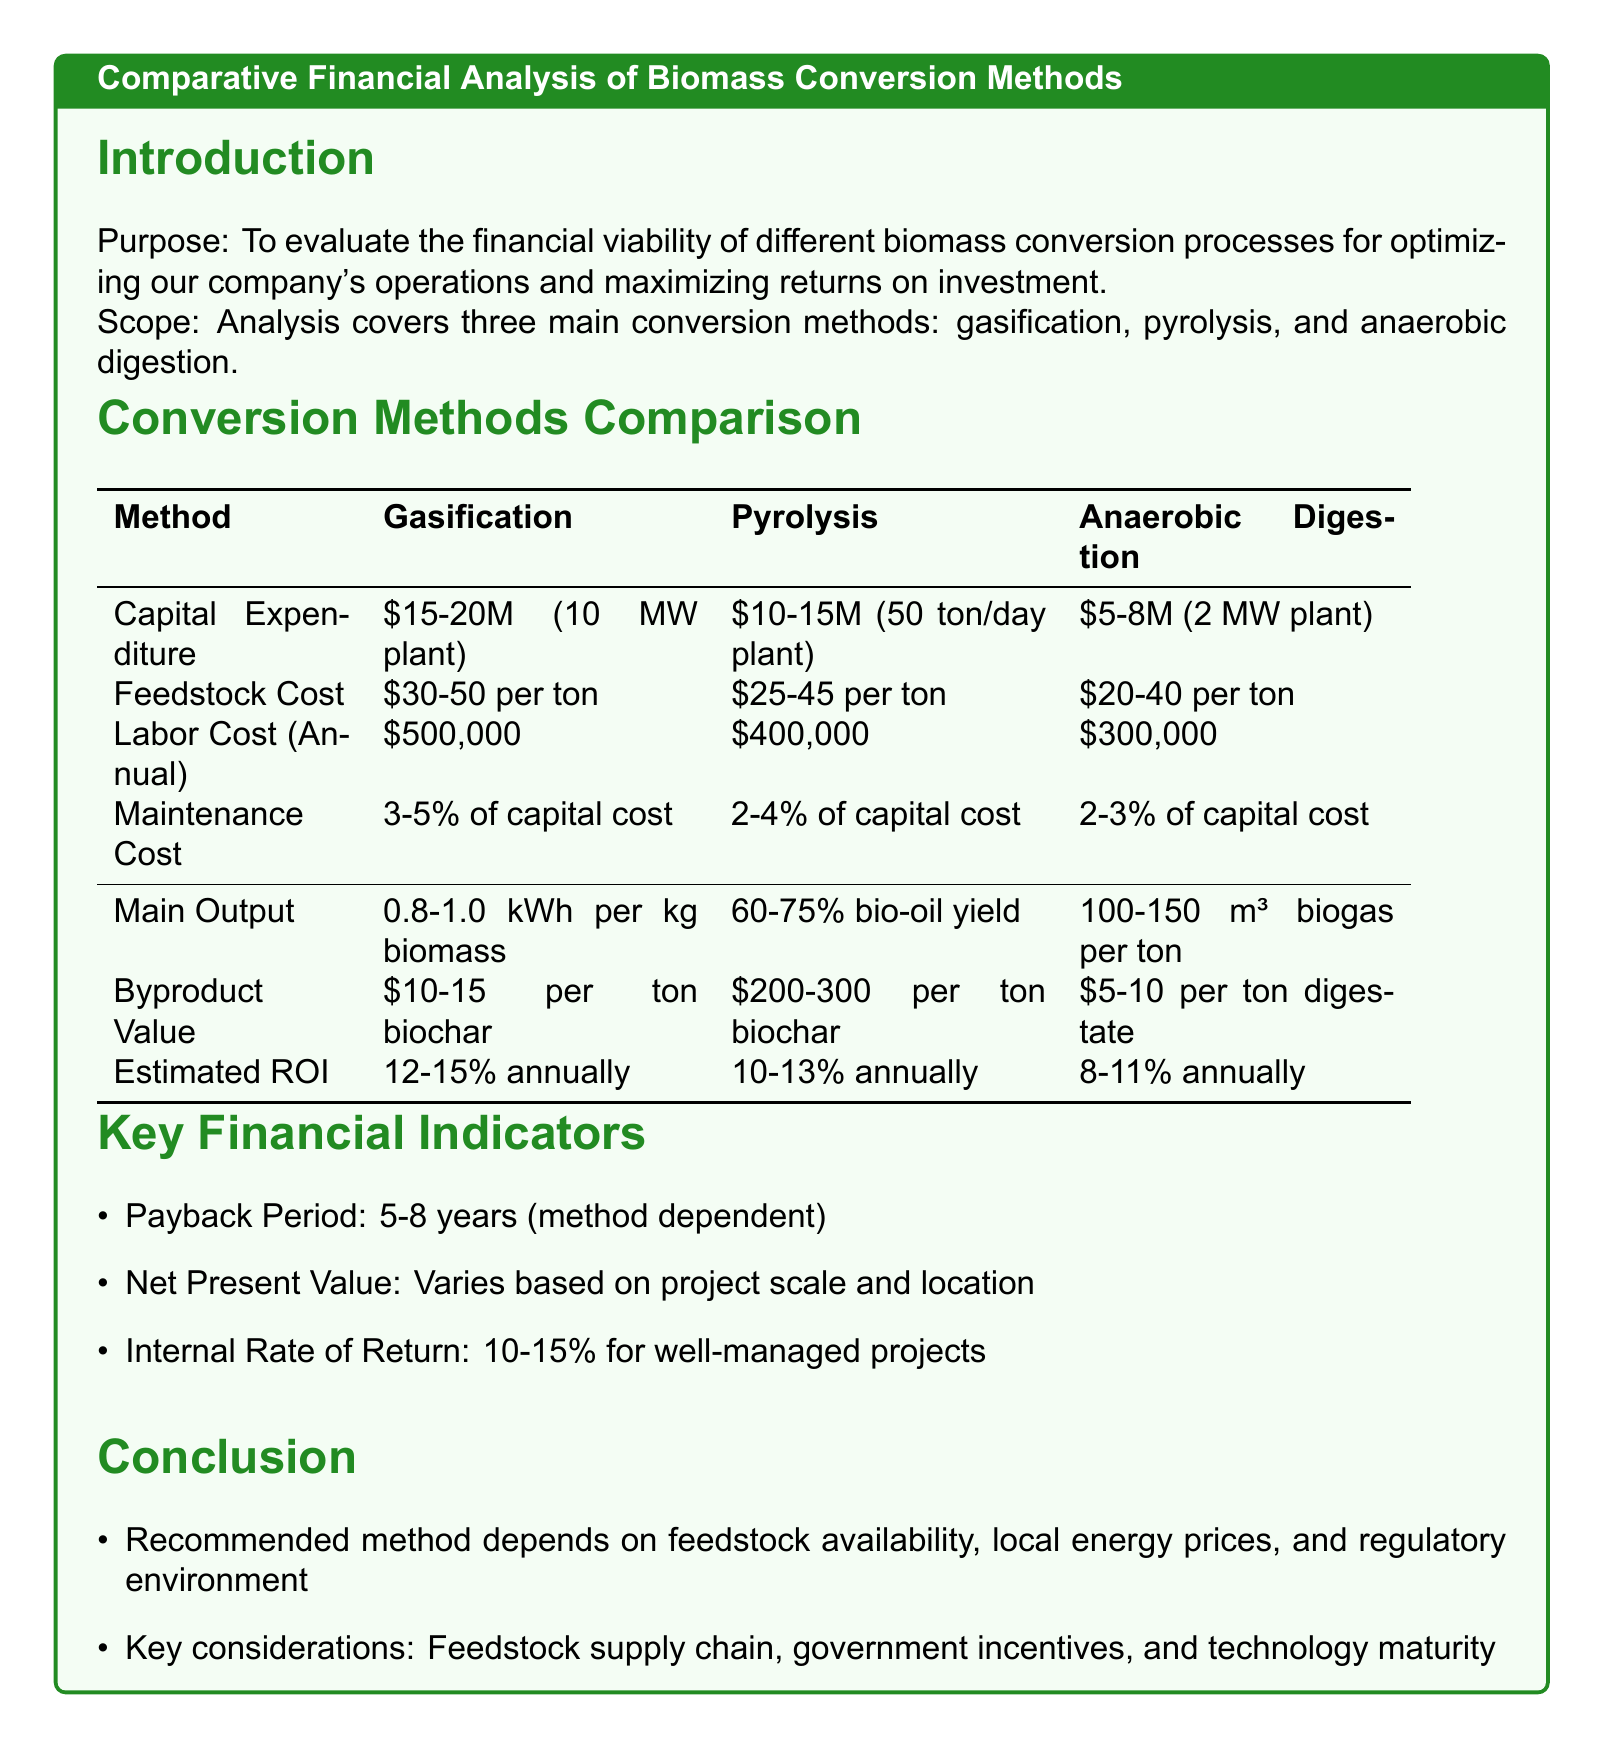What is the capital expenditure for gasification? The capital expenditure for gasification is stated as $15-20 million for a 10 MW plant.
Answer: $15-20 million What is the estimated ROI for anaerobic digestion? The estimated ROI for anaerobic digestion is detailed in the document as 8-11% annually.
Answer: 8-11% What maintenance cost percentage is associated with pyrolysis? The document specifies that the maintenance cost for pyrolysis is 2-4% of the capital cost annually.
Answer: 2-4% Which conversion method produces biogas? The document identifies anaerobic digestion as the method that produces biogas.
Answer: Anaerobic Digestion What is the range for feedstock costs in gasification? The range for feedstock costs in gasification is provided as $30-50 per ton.
Answer: $30-50 per ton What is the payback period range mentioned in the report? The report indicates the payback period range as 5-8 years depending on the method used.
Answer: 5-8 years Which method has the highest potential return from biochar? According to the document, pyrolysis has the highest potential return from biochar at $200-300 per ton.
Answer: Pyrolysis What are the key considerations mentioned in the conclusion? The key considerations are summarized as feedstock supply chain, government incentives, and technology maturity.
Answer: Feedstock supply chain, government incentives, and technology maturity What is the internal rate of return for well-managed projects? The internal rate of return for well-managed projects is stated as 10-15% in the document.
Answer: 10-15% 